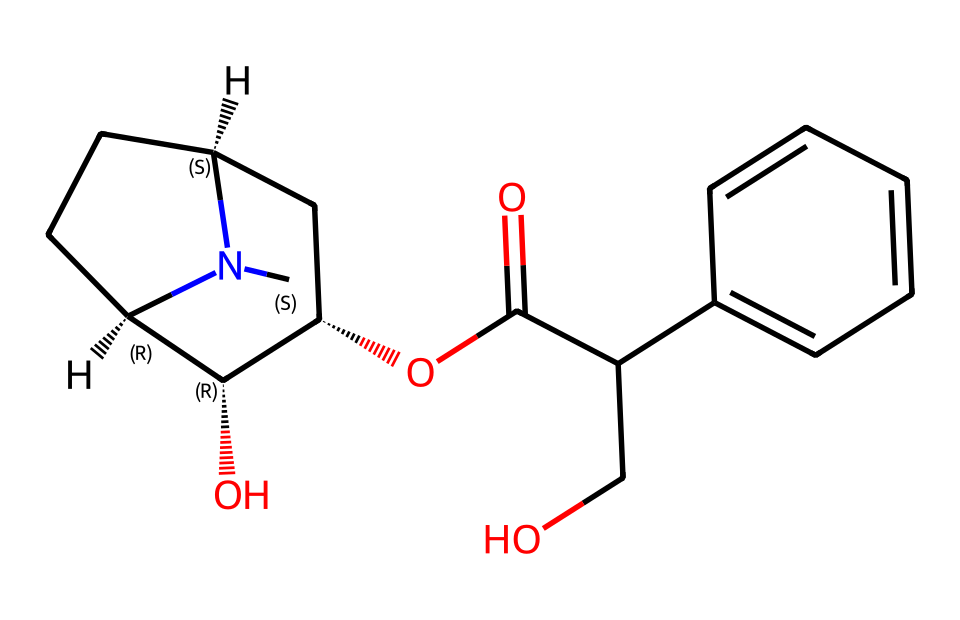What is the total number of carbon atoms in this chemical structure? By analyzing the SMILES representation, we can count the number of carbon (C) atoms present. The structure indicates various parts where carbon appears, both in chains and rings. Counting these gives us a total of 20 carbon atoms.
Answer: 20 How many nitrogen atoms are in this structure? The SMILES contains specific symbols that denote nitrogen atoms, which are represented by "N". Counting these provides the number of nitrogen atoms. In this case, there are 2 nitrogen atoms present.
Answer: 2 What functional group is associated with this alkaloid? Looking at the SMILES representation, we can identify the presence of a hydroxyl group (-OH), which is common in various alkaloids. In this case, the structure shows that one of the carbon atoms is bonded to a hydroxyl group, indicating its presence.
Answer: hydroxyl Which part of this compound contributes to its toxicity? Toxicity in many alkaloids is often linked to the nitrogen-containing part of their structure, which contributes to their pharmacological effects. In this compound, the atom connected to the cyclic structure and the nitrogen atoms are indicative of its potential toxicity in biological systems.
Answer: nitrogen What type of stereochemistry is present in this molecule? The SMILES notation includes symbols such as "@" which indicate chiral centers in the molecule. Analyzing the structure reveals that there are multiple centers of chirality, impacting its three-dimensional configuration. In this specific compound, there are 3 chiral centers.
Answer: 3 chiral centers 